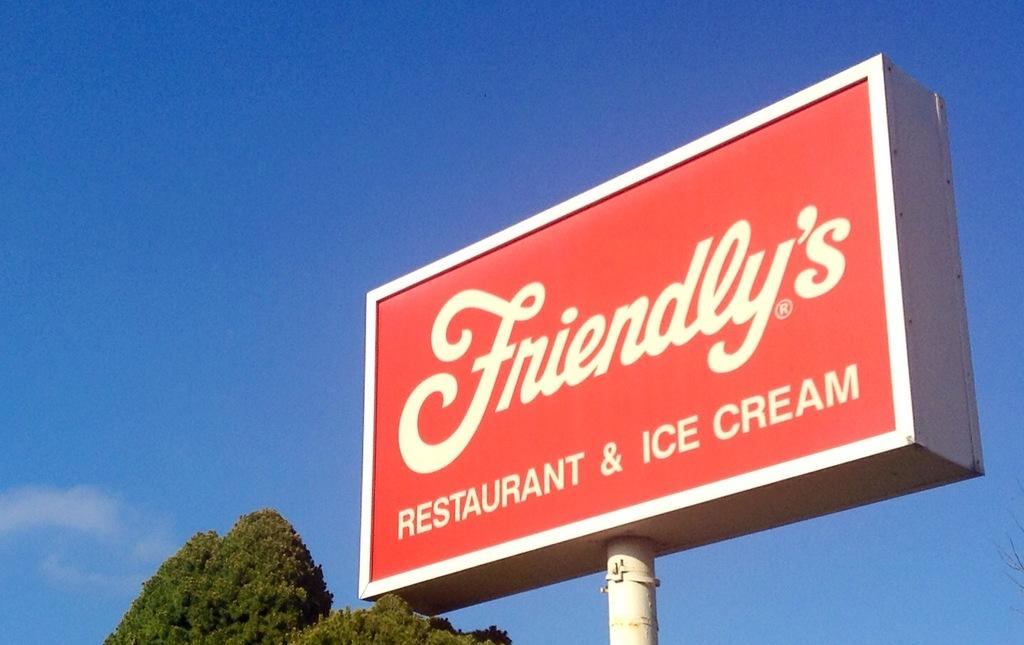<image>
Write a terse but informative summary of the picture. A red Friendly's ice cream and restaurant sign stands against a blue sky 